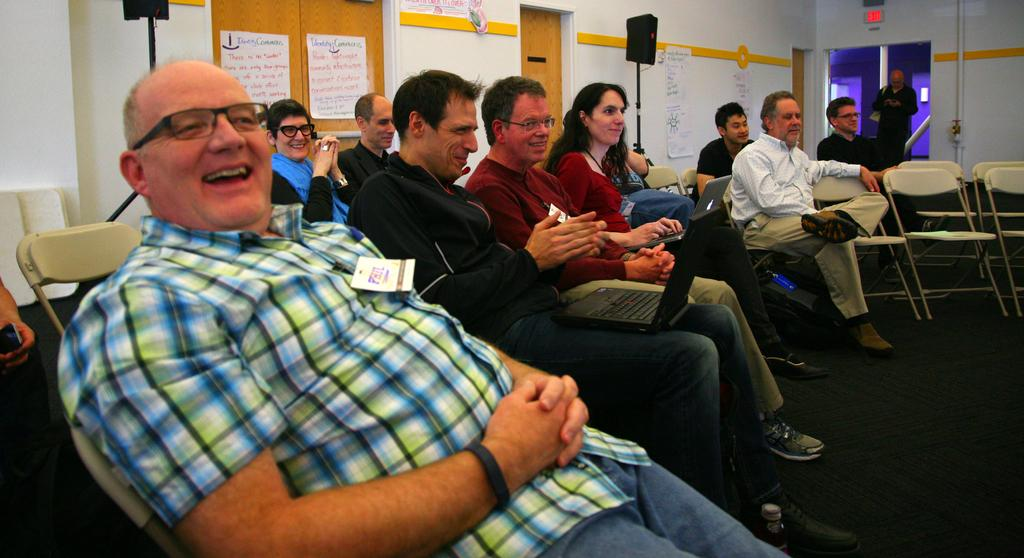What are the people in the image doing? There are persons sitting on chairs, and one person is standing. What objects are being held by some of the persons? Two persons are holding laptops. What can be seen on the floor in the image? The floor is visible. What is visible in the background of the image? There is a wall, speakers with stands, and papers in the background. What type of neck can be seen on the cloud in the image? There is no cloud present in the image, and therefore no neck can be observed. 